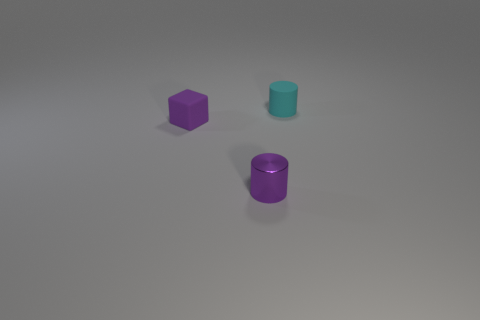Add 2 tiny cyan rubber cylinders. How many objects exist? 5 Subtract all cylinders. How many objects are left? 1 Subtract all blue cylinders. Subtract all cyan blocks. How many cylinders are left? 2 Subtract all blue balls. How many purple cylinders are left? 1 Subtract all cyan rubber cylinders. Subtract all gray matte spheres. How many objects are left? 2 Add 3 cylinders. How many cylinders are left? 5 Add 2 small brown matte blocks. How many small brown matte blocks exist? 2 Subtract 1 cyan cylinders. How many objects are left? 2 